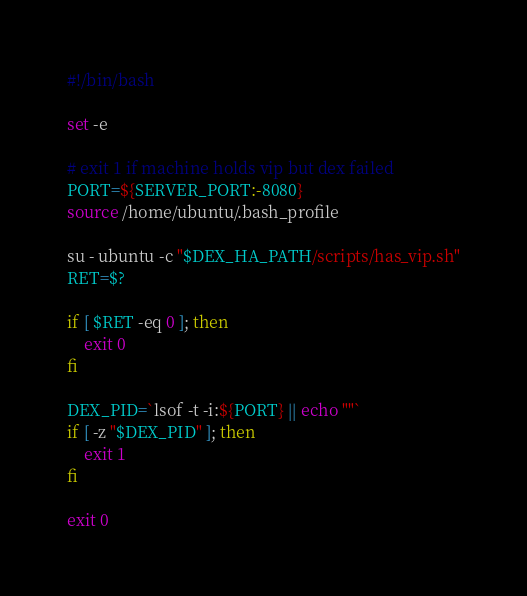<code> <loc_0><loc_0><loc_500><loc_500><_Bash_>#!/bin/bash

set -e

# exit 1 if machine holds vip but dex failed
PORT=${SERVER_PORT:-8080}
source /home/ubuntu/.bash_profile

su - ubuntu -c "$DEX_HA_PATH/scripts/has_vip.sh"
RET=$?

if [ $RET -eq 0 ]; then
    exit 0
fi

DEX_PID=`lsof -t -i:${PORT} || echo ""`
if [ -z "$DEX_PID" ]; then
    exit 1
fi

exit 0
</code> 